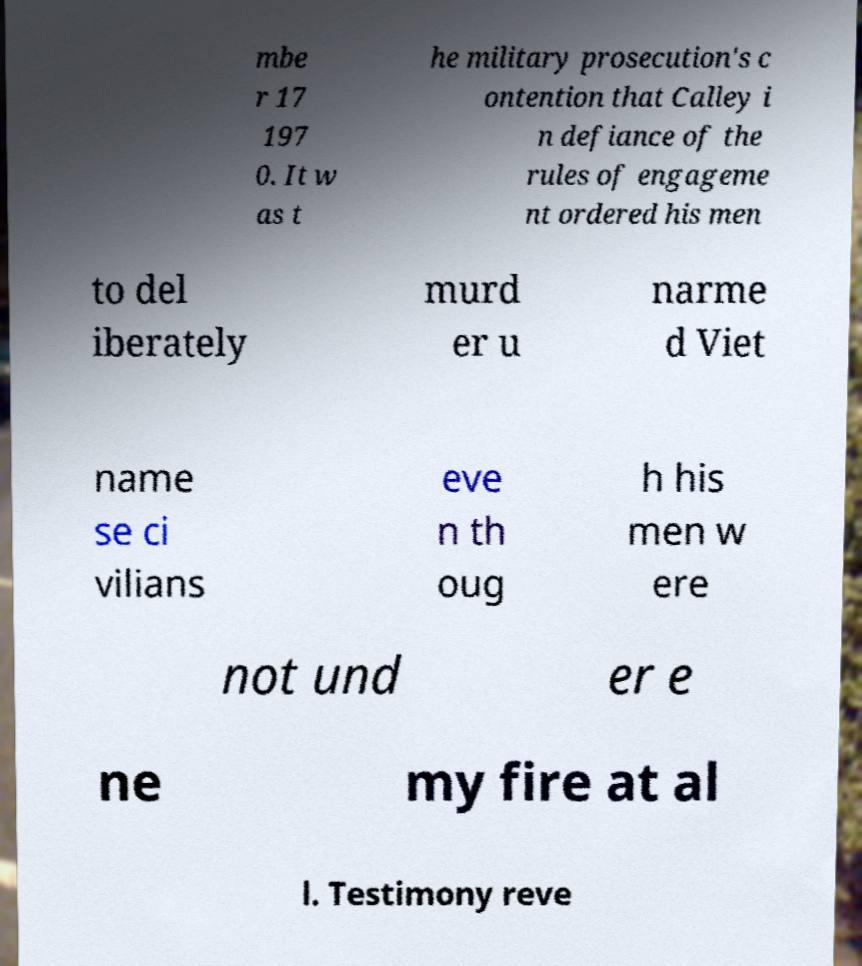For documentation purposes, I need the text within this image transcribed. Could you provide that? mbe r 17 197 0. It w as t he military prosecution's c ontention that Calley i n defiance of the rules of engageme nt ordered his men to del iberately murd er u narme d Viet name se ci vilians eve n th oug h his men w ere not und er e ne my fire at al l. Testimony reve 